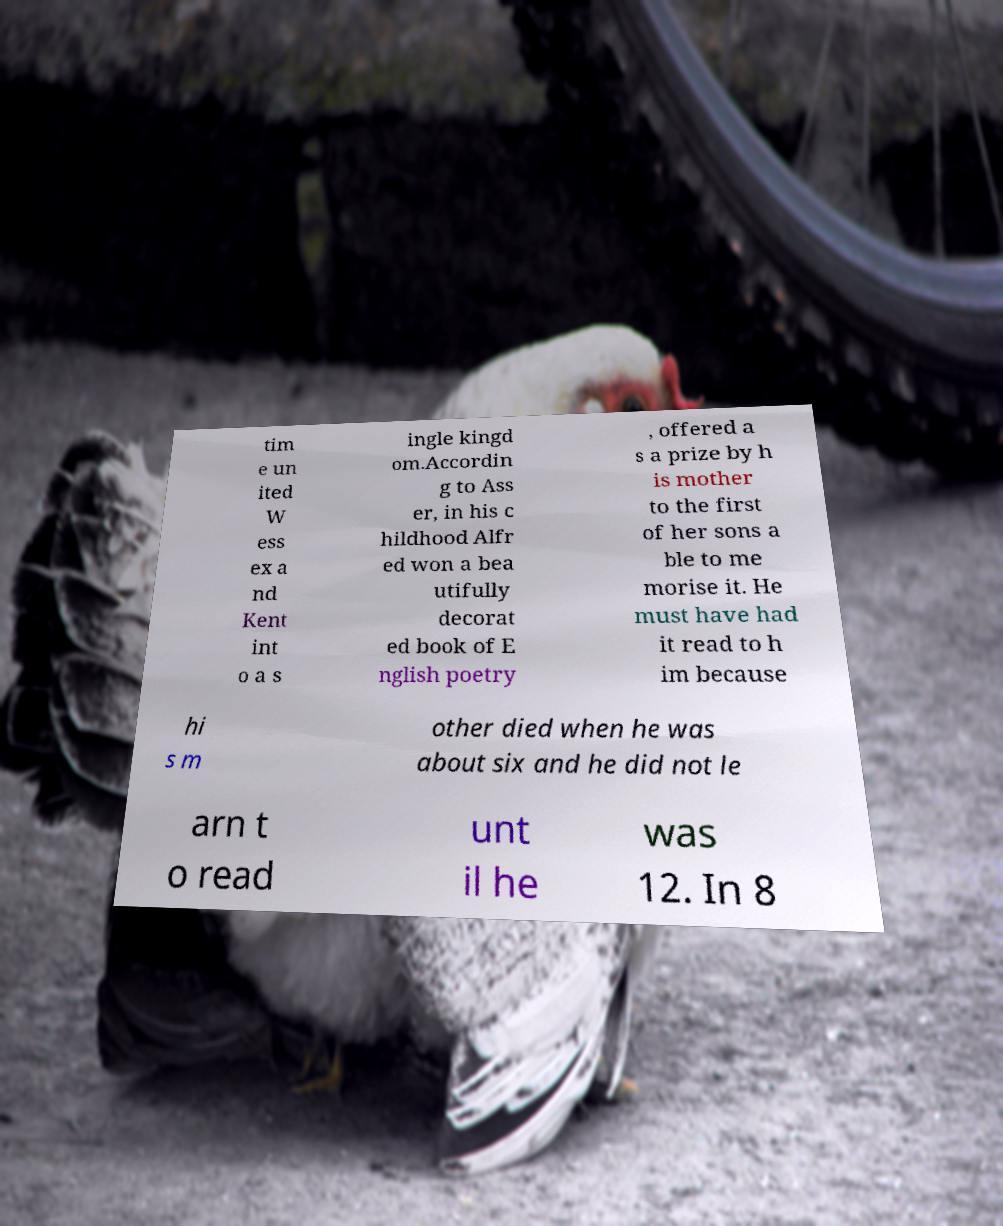For documentation purposes, I need the text within this image transcribed. Could you provide that? tim e un ited W ess ex a nd Kent int o a s ingle kingd om.Accordin g to Ass er, in his c hildhood Alfr ed won a bea utifully decorat ed book of E nglish poetry , offered a s a prize by h is mother to the first of her sons a ble to me morise it. He must have had it read to h im because hi s m other died when he was about six and he did not le arn t o read unt il he was 12. In 8 